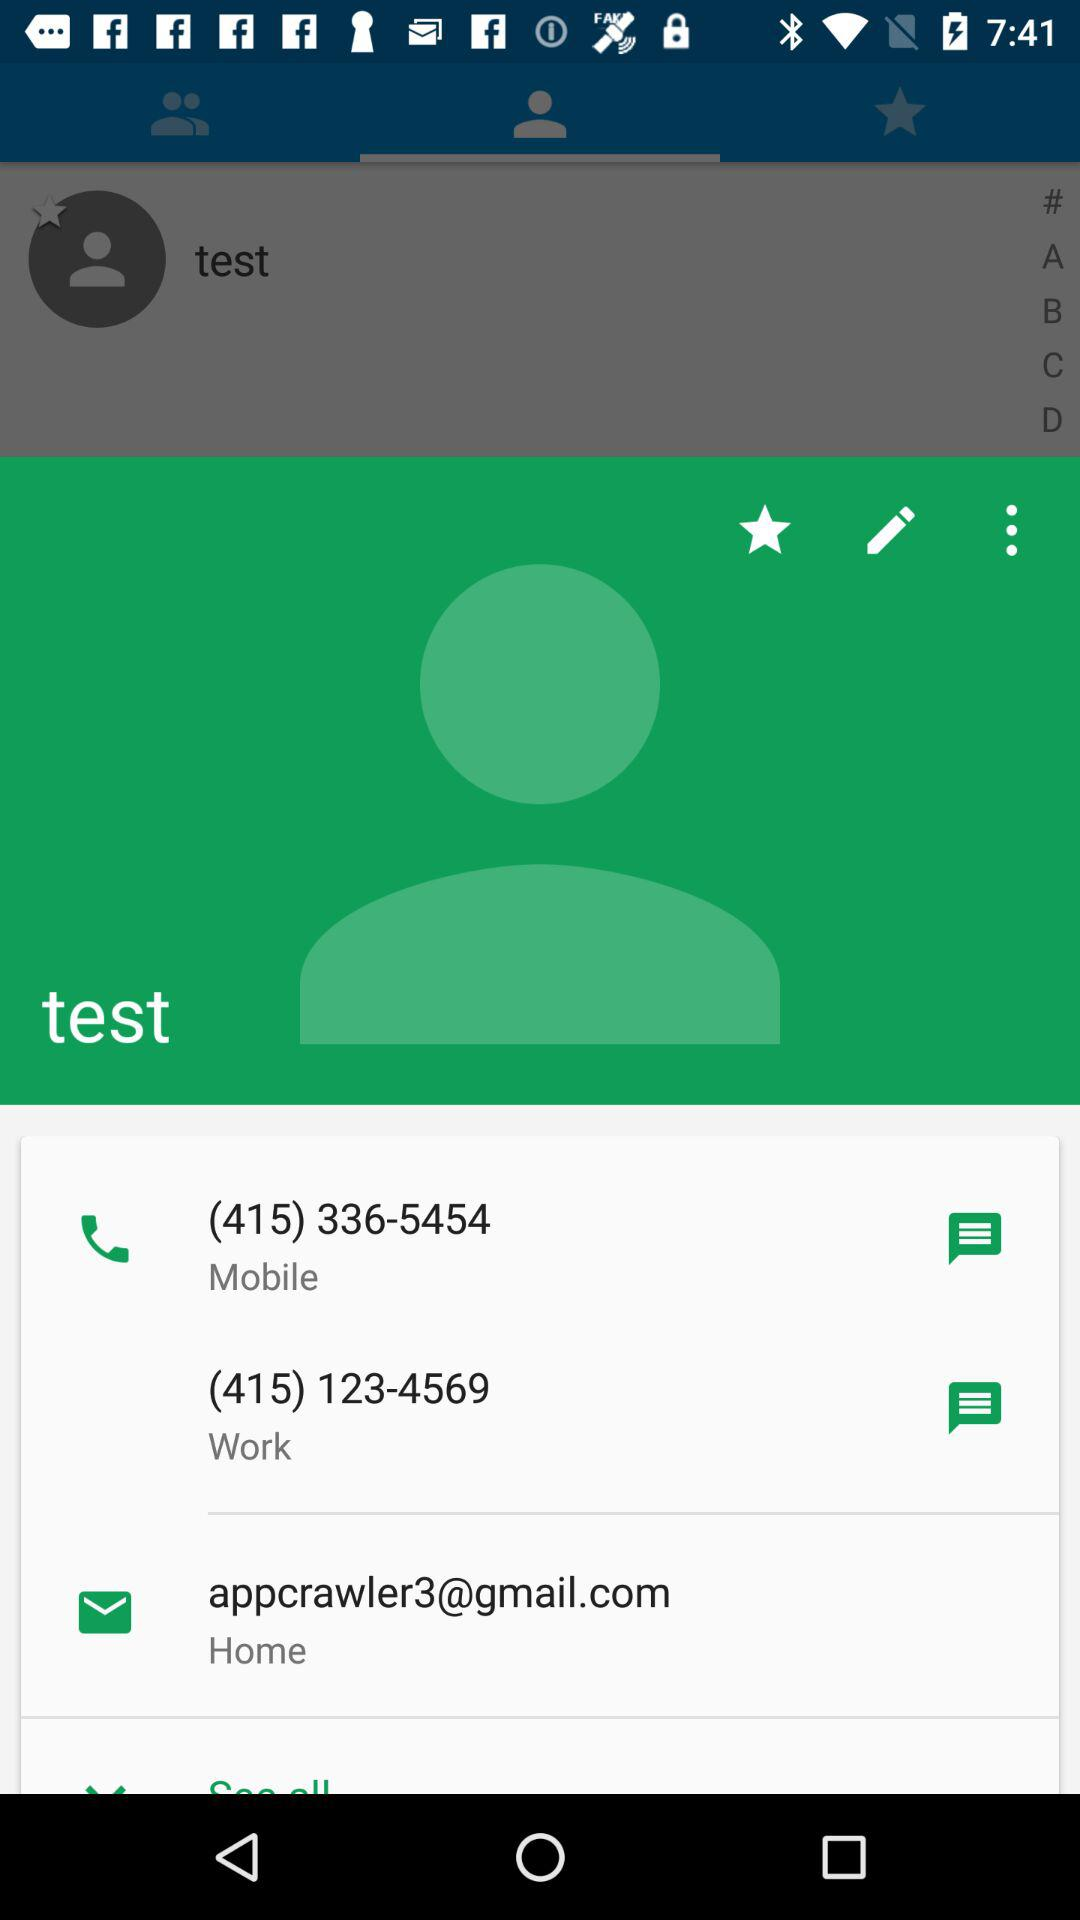What is the user name? The user name is test. 